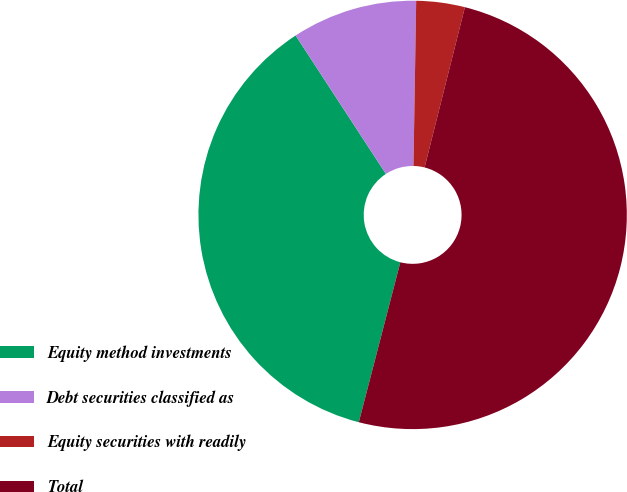<chart> <loc_0><loc_0><loc_500><loc_500><pie_chart><fcel>Equity method investments<fcel>Debt securities classified as<fcel>Equity securities with readily<fcel>Total<nl><fcel>36.76%<fcel>9.46%<fcel>3.66%<fcel>50.12%<nl></chart> 